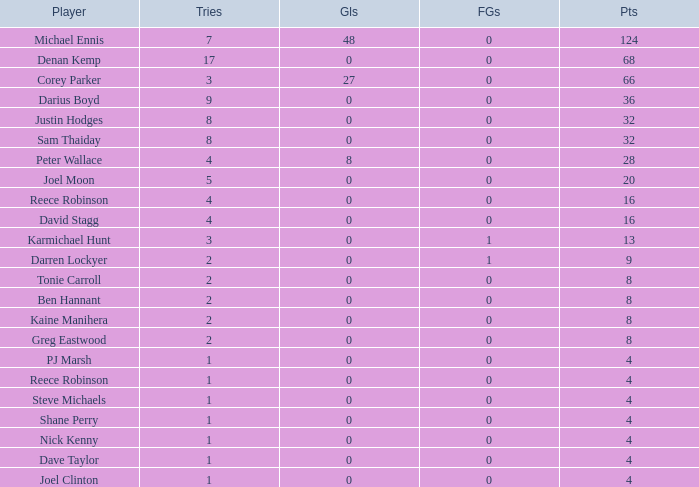What is the lowest tries the player with more than 0 goals, 28 points, and more than 0 field goals have? None. 